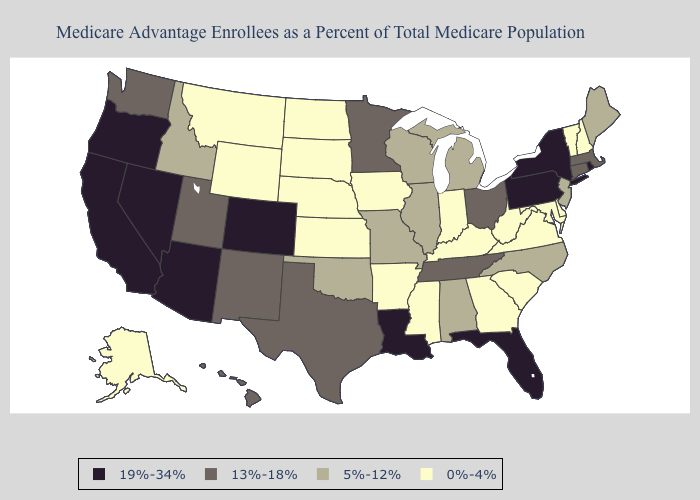Which states have the highest value in the USA?
Be succinct. Arizona, California, Colorado, Florida, Louisiana, Nevada, New York, Oregon, Pennsylvania, Rhode Island. What is the highest value in states that border Florida?
Give a very brief answer. 5%-12%. Which states have the lowest value in the USA?
Write a very short answer. Alaska, Arkansas, Delaware, Georgia, Iowa, Indiana, Kansas, Kentucky, Maryland, Mississippi, Montana, North Dakota, Nebraska, New Hampshire, South Carolina, South Dakota, Virginia, Vermont, West Virginia, Wyoming. Among the states that border Arkansas , does Louisiana have the highest value?
Concise answer only. Yes. Name the states that have a value in the range 19%-34%?
Concise answer only. Arizona, California, Colorado, Florida, Louisiana, Nevada, New York, Oregon, Pennsylvania, Rhode Island. What is the value of Kentucky?
Write a very short answer. 0%-4%. What is the value of Louisiana?
Give a very brief answer. 19%-34%. Name the states that have a value in the range 13%-18%?
Answer briefly. Connecticut, Hawaii, Massachusetts, Minnesota, New Mexico, Ohio, Tennessee, Texas, Utah, Washington. How many symbols are there in the legend?
Be succinct. 4. Name the states that have a value in the range 13%-18%?
Answer briefly. Connecticut, Hawaii, Massachusetts, Minnesota, New Mexico, Ohio, Tennessee, Texas, Utah, Washington. How many symbols are there in the legend?
Write a very short answer. 4. What is the highest value in states that border Louisiana?
Write a very short answer. 13%-18%. Among the states that border Nebraska , which have the lowest value?
Concise answer only. Iowa, Kansas, South Dakota, Wyoming. What is the value of Nebraska?
Quick response, please. 0%-4%. Among the states that border New York , does Massachusetts have the lowest value?
Answer briefly. No. 